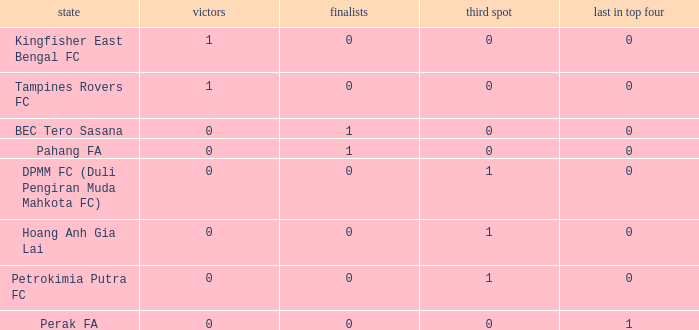Name the highest 3rd place for nation of perak fa 0.0. 